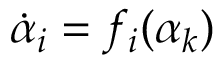<formula> <loc_0><loc_0><loc_500><loc_500>\dot { \alpha } _ { i } = f _ { i } ( \alpha _ { k } )</formula> 